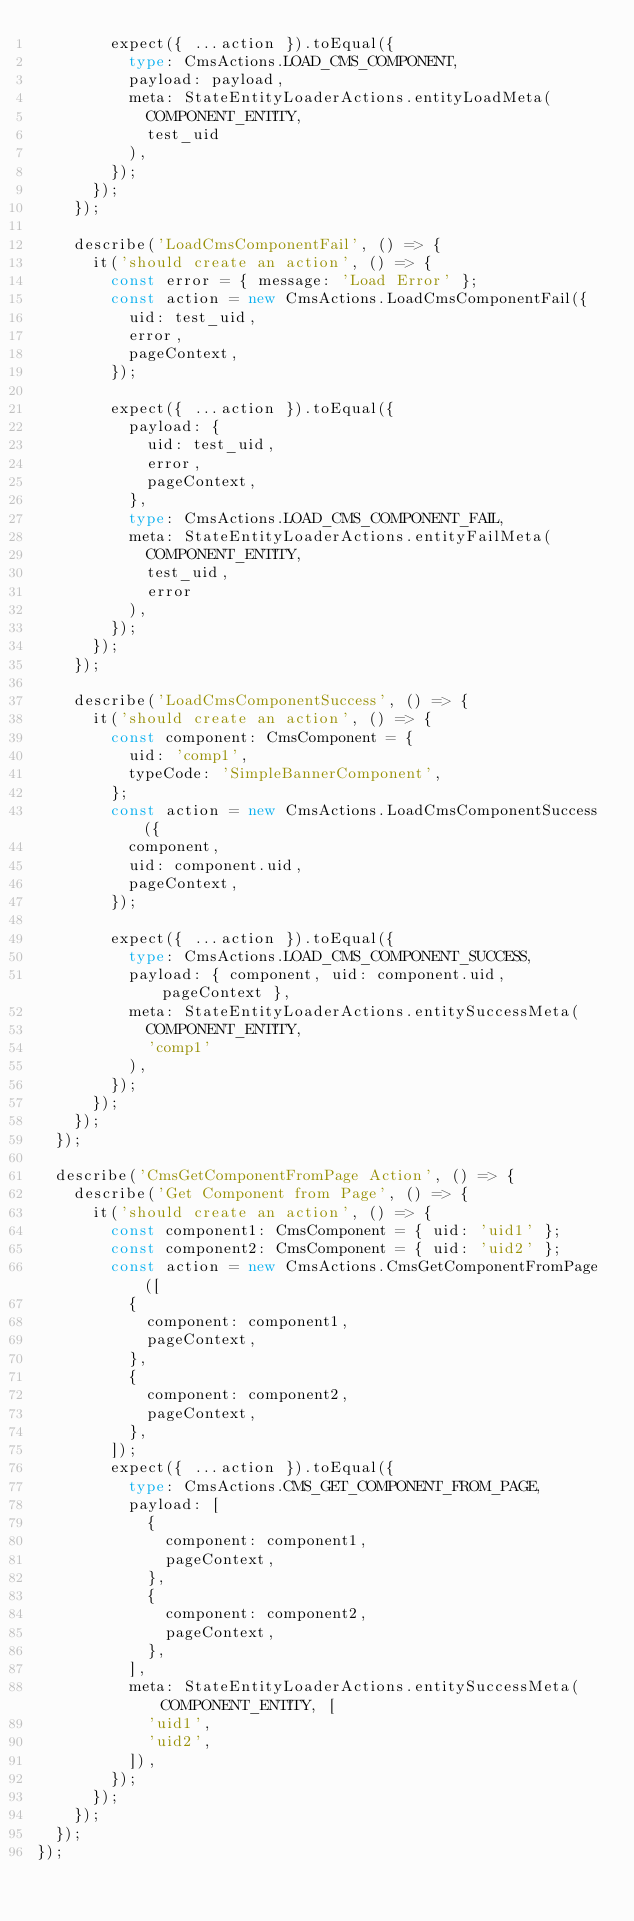Convert code to text. <code><loc_0><loc_0><loc_500><loc_500><_TypeScript_>        expect({ ...action }).toEqual({
          type: CmsActions.LOAD_CMS_COMPONENT,
          payload: payload,
          meta: StateEntityLoaderActions.entityLoadMeta(
            COMPONENT_ENTITY,
            test_uid
          ),
        });
      });
    });

    describe('LoadCmsComponentFail', () => {
      it('should create an action', () => {
        const error = { message: 'Load Error' };
        const action = new CmsActions.LoadCmsComponentFail({
          uid: test_uid,
          error,
          pageContext,
        });

        expect({ ...action }).toEqual({
          payload: {
            uid: test_uid,
            error,
            pageContext,
          },
          type: CmsActions.LOAD_CMS_COMPONENT_FAIL,
          meta: StateEntityLoaderActions.entityFailMeta(
            COMPONENT_ENTITY,
            test_uid,
            error
          ),
        });
      });
    });

    describe('LoadCmsComponentSuccess', () => {
      it('should create an action', () => {
        const component: CmsComponent = {
          uid: 'comp1',
          typeCode: 'SimpleBannerComponent',
        };
        const action = new CmsActions.LoadCmsComponentSuccess({
          component,
          uid: component.uid,
          pageContext,
        });

        expect({ ...action }).toEqual({
          type: CmsActions.LOAD_CMS_COMPONENT_SUCCESS,
          payload: { component, uid: component.uid, pageContext },
          meta: StateEntityLoaderActions.entitySuccessMeta(
            COMPONENT_ENTITY,
            'comp1'
          ),
        });
      });
    });
  });

  describe('CmsGetComponentFromPage Action', () => {
    describe('Get Component from Page', () => {
      it('should create an action', () => {
        const component1: CmsComponent = { uid: 'uid1' };
        const component2: CmsComponent = { uid: 'uid2' };
        const action = new CmsActions.CmsGetComponentFromPage([
          {
            component: component1,
            pageContext,
          },
          {
            component: component2,
            pageContext,
          },
        ]);
        expect({ ...action }).toEqual({
          type: CmsActions.CMS_GET_COMPONENT_FROM_PAGE,
          payload: [
            {
              component: component1,
              pageContext,
            },
            {
              component: component2,
              pageContext,
            },
          ],
          meta: StateEntityLoaderActions.entitySuccessMeta(COMPONENT_ENTITY, [
            'uid1',
            'uid2',
          ]),
        });
      });
    });
  });
});
</code> 